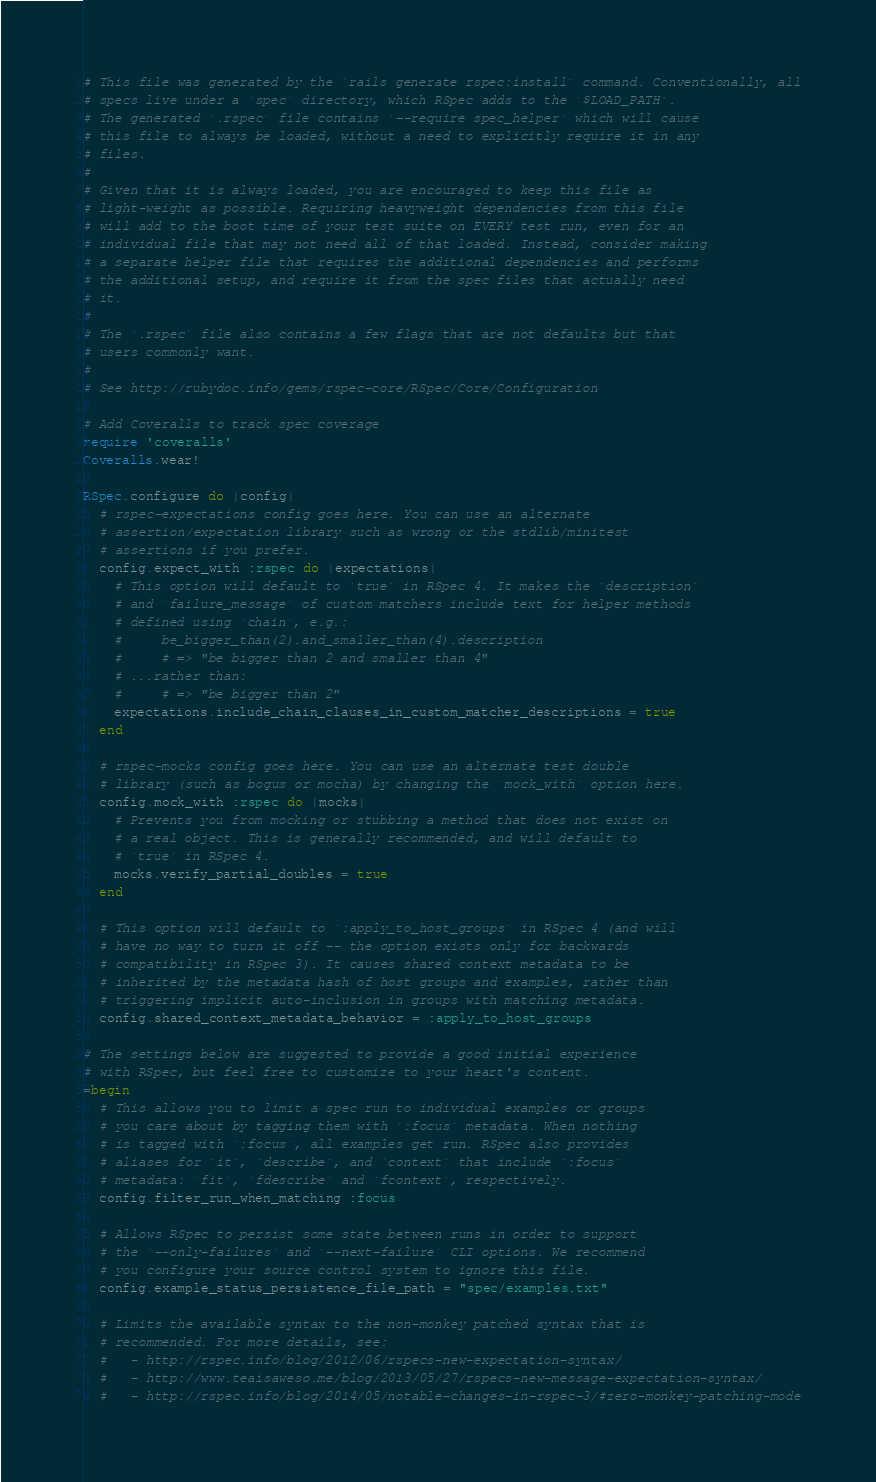<code> <loc_0><loc_0><loc_500><loc_500><_Ruby_># This file was generated by the `rails generate rspec:install` command. Conventionally, all
# specs live under a `spec` directory, which RSpec adds to the `$LOAD_PATH`.
# The generated `.rspec` file contains `--require spec_helper` which will cause
# this file to always be loaded, without a need to explicitly require it in any
# files.
#
# Given that it is always loaded, you are encouraged to keep this file as
# light-weight as possible. Requiring heavyweight dependencies from this file
# will add to the boot time of your test suite on EVERY test run, even for an
# individual file that may not need all of that loaded. Instead, consider making
# a separate helper file that requires the additional dependencies and performs
# the additional setup, and require it from the spec files that actually need
# it.
#
# The `.rspec` file also contains a few flags that are not defaults but that
# users commonly want.
#
# See http://rubydoc.info/gems/rspec-core/RSpec/Core/Configuration

# Add Coveralls to track spec coverage
require 'coveralls'
Coveralls.wear!

RSpec.configure do |config|
  # rspec-expectations config goes here. You can use an alternate
  # assertion/expectation library such as wrong or the stdlib/minitest
  # assertions if you prefer.
  config.expect_with :rspec do |expectations|
    # This option will default to `true` in RSpec 4. It makes the `description`
    # and `failure_message` of custom matchers include text for helper methods
    # defined using `chain`, e.g.:
    #     be_bigger_than(2).and_smaller_than(4).description
    #     # => "be bigger than 2 and smaller than 4"
    # ...rather than:
    #     # => "be bigger than 2"
    expectations.include_chain_clauses_in_custom_matcher_descriptions = true
  end

  # rspec-mocks config goes here. You can use an alternate test double
  # library (such as bogus or mocha) by changing the `mock_with` option here.
  config.mock_with :rspec do |mocks|
    # Prevents you from mocking or stubbing a method that does not exist on
    # a real object. This is generally recommended, and will default to
    # `true` in RSpec 4.
    mocks.verify_partial_doubles = true
  end

  # This option will default to `:apply_to_host_groups` in RSpec 4 (and will
  # have no way to turn it off -- the option exists only for backwards
  # compatibility in RSpec 3). It causes shared context metadata to be
  # inherited by the metadata hash of host groups and examples, rather than
  # triggering implicit auto-inclusion in groups with matching metadata.
  config.shared_context_metadata_behavior = :apply_to_host_groups

# The settings below are suggested to provide a good initial experience
# with RSpec, but feel free to customize to your heart's content.
=begin
  # This allows you to limit a spec run to individual examples or groups
  # you care about by tagging them with `:focus` metadata. When nothing
  # is tagged with `:focus`, all examples get run. RSpec also provides
  # aliases for `it`, `describe`, and `context` that include `:focus`
  # metadata: `fit`, `fdescribe` and `fcontext`, respectively.
  config.filter_run_when_matching :focus

  # Allows RSpec to persist some state between runs in order to support
  # the `--only-failures` and `--next-failure` CLI options. We recommend
  # you configure your source control system to ignore this file.
  config.example_status_persistence_file_path = "spec/examples.txt"

  # Limits the available syntax to the non-monkey patched syntax that is
  # recommended. For more details, see:
  #   - http://rspec.info/blog/2012/06/rspecs-new-expectation-syntax/
  #   - http://www.teaisaweso.me/blog/2013/05/27/rspecs-new-message-expectation-syntax/
  #   - http://rspec.info/blog/2014/05/notable-changes-in-rspec-3/#zero-monkey-patching-mode</code> 